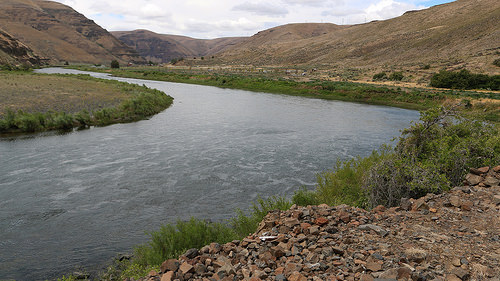<image>
Is the river next to the stone? Yes. The river is positioned adjacent to the stone, located nearby in the same general area. 